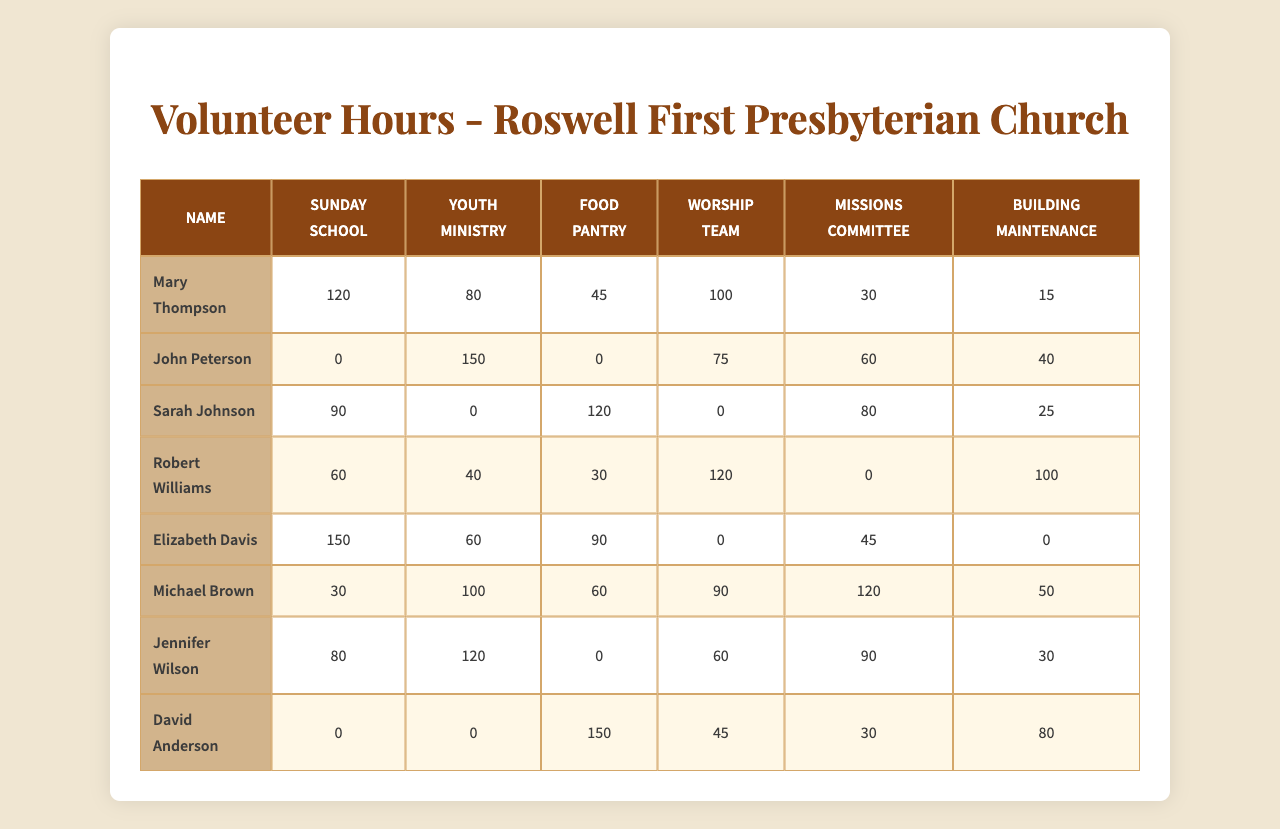What is the total number of volunteer hours contributed by Michael Brown? For Michael Brown, the volunteer hours across all programs are: Sunday School (30) + Youth Ministry (100) + Food Pantry (60) + Worship Team (90) + Missions Committee (120) + Building Maintenance (50). Summing these gives 30 + 100 + 60 + 90 + 120 + 50 = 450 hours.
Answer: 450 Who contributed the most hours to the Worship Team? By comparing the Worship Team contribution across all members, the highest is Robert Williams with 120 hours.
Answer: Robert Williams Did any member contribute hours to the Food Pantry but not to the Youth Ministry? Looking at the table, Mary Thompson (45 hours in Food Pantry, 0 in Youth Ministry), and Sarah Johnson (120 hours in Food Pantry, 0 in Youth Ministry) both fit this criterion.
Answer: Yes What is the average number of hours contributed to the Sunday School program? The contributions to Sunday School are: Mary Thompson (120), John Peterson (0), Sarah Johnson (90), Robert Williams (60), Elizabeth Davis (150), Michael Brown (30), and Jennifer Wilson (80). The sum is 120 + 0 + 90 + 60 + 150 + 30 + 80 = 530, and there are 7 members, so the average is 530 / 7 ≈ 75.71 hours.
Answer: 75.71 How many total hours did David Anderson contribute across all programs? For David Anderson, the volunteer hours are: Sunday School (0) + Youth Ministry (0) + Food Pantry (150) + Worship Team (45) + Missions Committee (30) + Building Maintenance (80). Adding these gives 0 + 0 + 150 + 45 + 30 + 80 = 305 hours.
Answer: 305 Which committee received the least total volunteer hours? Summing the totals for each committee: Sunday School (450), Youth Ministry (450), Food Pantry (405), Worship Team (390), Missions Committee (405), and Building Maintenance (305). The smallest total is for Building Maintenance with 305 hours.
Answer: Building Maintenance How many more hours did Sarah Johnson contribute to the Food Pantry compared to the Sunday School? Sarah Johnson contributed 120 hours to the Food Pantry and 90 hours to the Sunday School. The difference is 120 - 90 = 30 hours more to the Food Pantry.
Answer: 30 Which volunteer contributed the least hours overall? Summing up the total hours for each member, we find that John Peterson contributed a total of 325 hours (0 + 150 + 0 + 75 + 60 + 40). This is the lowest total among all volunteers.
Answer: John Peterson What is the total volunteer hours for the Missions Committee? Adding the hours for the Missions Committee: Mary Thompson (30) + John Peterson (60) + Sarah Johnson (80) + Robert Williams (0) + Elizabeth Davis (45) + Michael Brown (120) + Jennifer Wilson (90) + David Anderson (30). The total is 30 + 60 + 80 + 0 + 45 + 120 + 90 + 30 = 455 hours.
Answer: 455 How many volunteers contributed to the Youth Ministry and also had volunteer hours in Building Maintenance? The members who contributed to both Youth Ministry and Building Maintenance are John Peterson, Robert Williams, Michael Brown, and Jennifer Wilson. That accounts for 4 volunteers.
Answer: 4 What was the total contribution of the congregation in Worship Team hours? The hours for the Worship Team are: 100 (Mary Thompson) + 75 (John Peterson) + 0 (Sarah Johnson) + 120 (Robert Williams) + 0 (Elizabeth Davis) + 90 (Michael Brown) + 60 (Jennifer Wilson) + 45 (David Anderson). Adding these gives 100 + 75 + 0 + 120 + 0 + 90 + 60 + 45 = 490 hours.
Answer: 490 